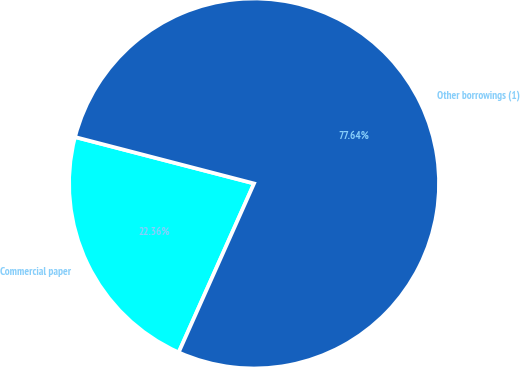Convert chart. <chart><loc_0><loc_0><loc_500><loc_500><pie_chart><fcel>Commercial paper<fcel>Other borrowings (1)<nl><fcel>22.36%<fcel>77.64%<nl></chart> 